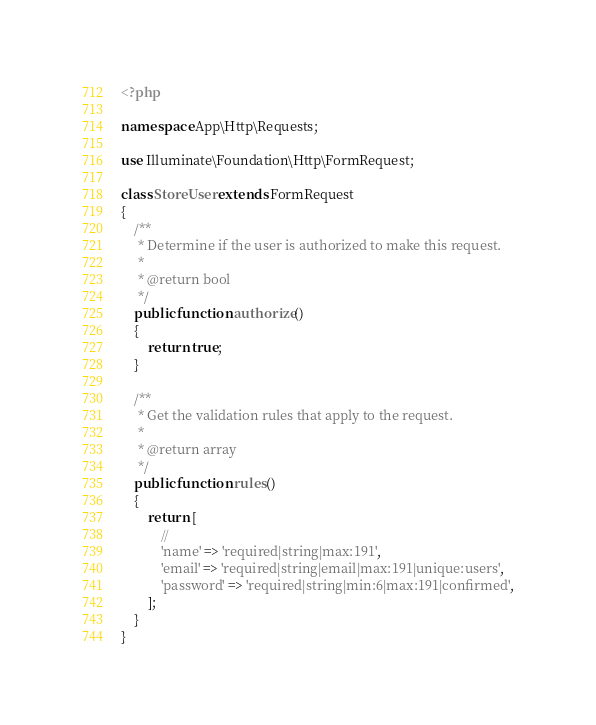Convert code to text. <code><loc_0><loc_0><loc_500><loc_500><_PHP_><?php

namespace App\Http\Requests;

use Illuminate\Foundation\Http\FormRequest;

class StoreUser extends FormRequest
{
    /**
     * Determine if the user is authorized to make this request.
     *
     * @return bool
     */
    public function authorize()
    {
        return true;
    }

    /**
     * Get the validation rules that apply to the request.
     *
     * @return array
     */
    public function rules()
    {
        return [
            //
            'name' => 'required|string|max:191',
            'email' => 'required|string|email|max:191|unique:users',
            'password' => 'required|string|min:6|max:191|confirmed',
        ];
    }
}
</code> 